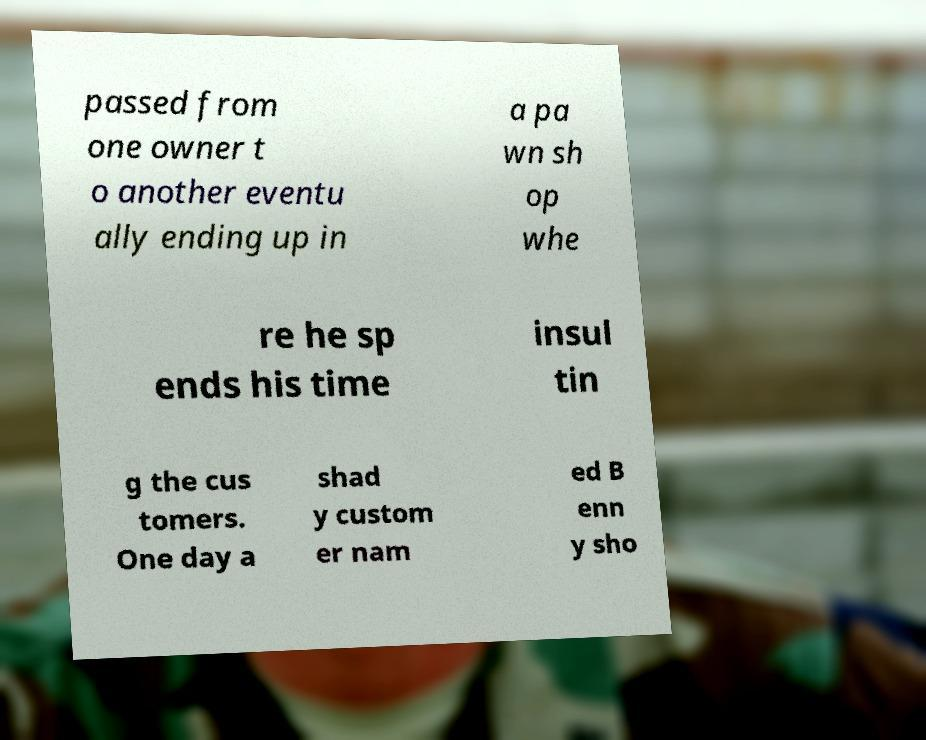Can you read and provide the text displayed in the image?This photo seems to have some interesting text. Can you extract and type it out for me? passed from one owner t o another eventu ally ending up in a pa wn sh op whe re he sp ends his time insul tin g the cus tomers. One day a shad y custom er nam ed B enn y sho 